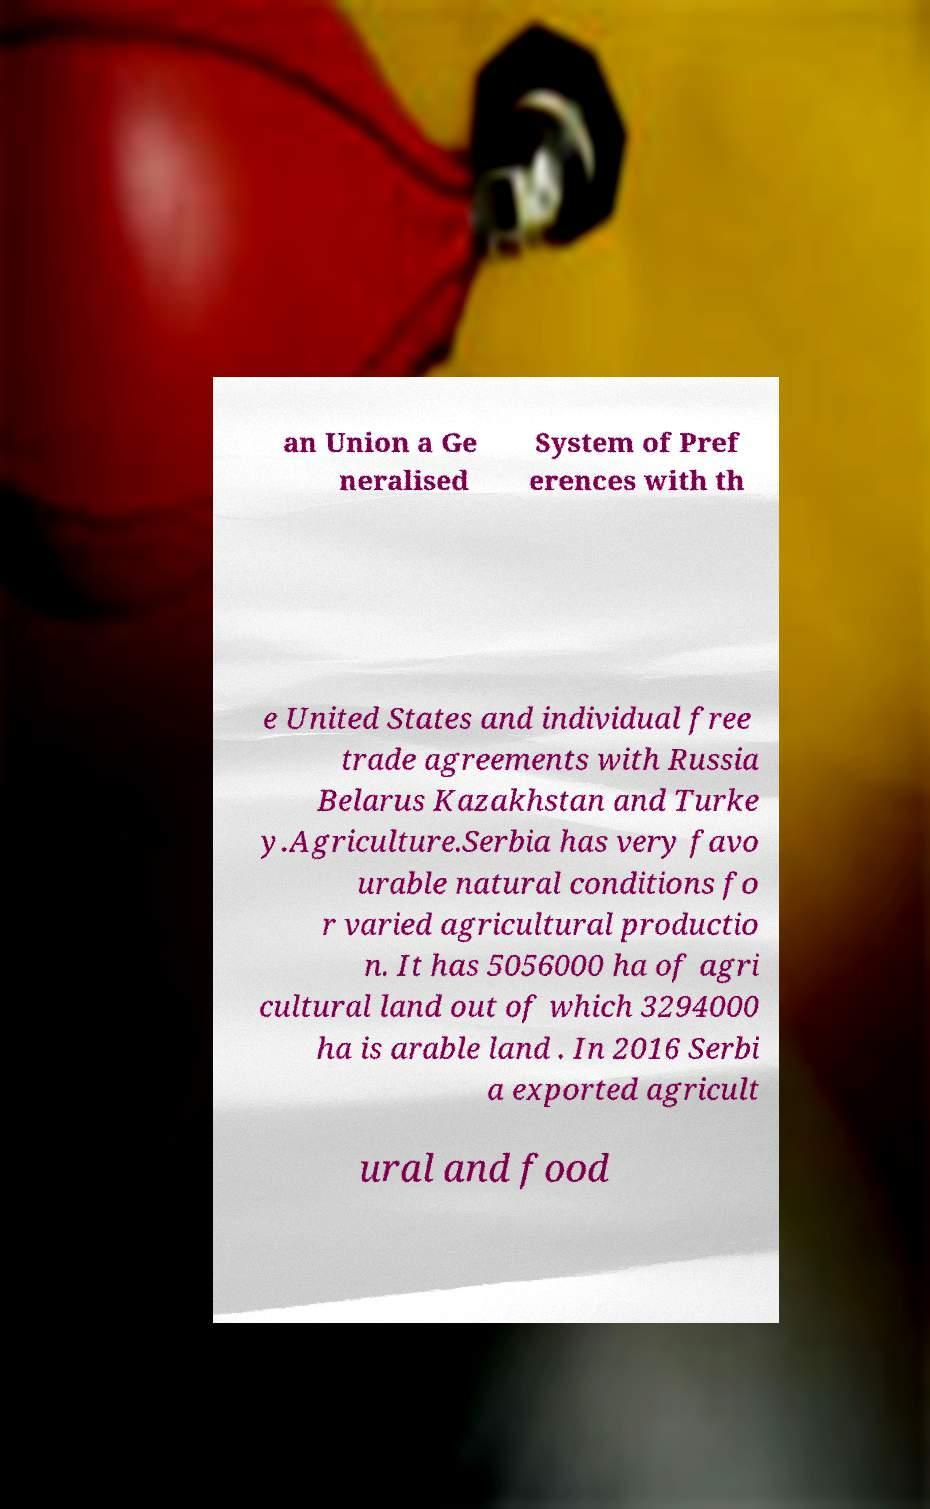I need the written content from this picture converted into text. Can you do that? an Union a Ge neralised System of Pref erences with th e United States and individual free trade agreements with Russia Belarus Kazakhstan and Turke y.Agriculture.Serbia has very favo urable natural conditions fo r varied agricultural productio n. It has 5056000 ha of agri cultural land out of which 3294000 ha is arable land . In 2016 Serbi a exported agricult ural and food 